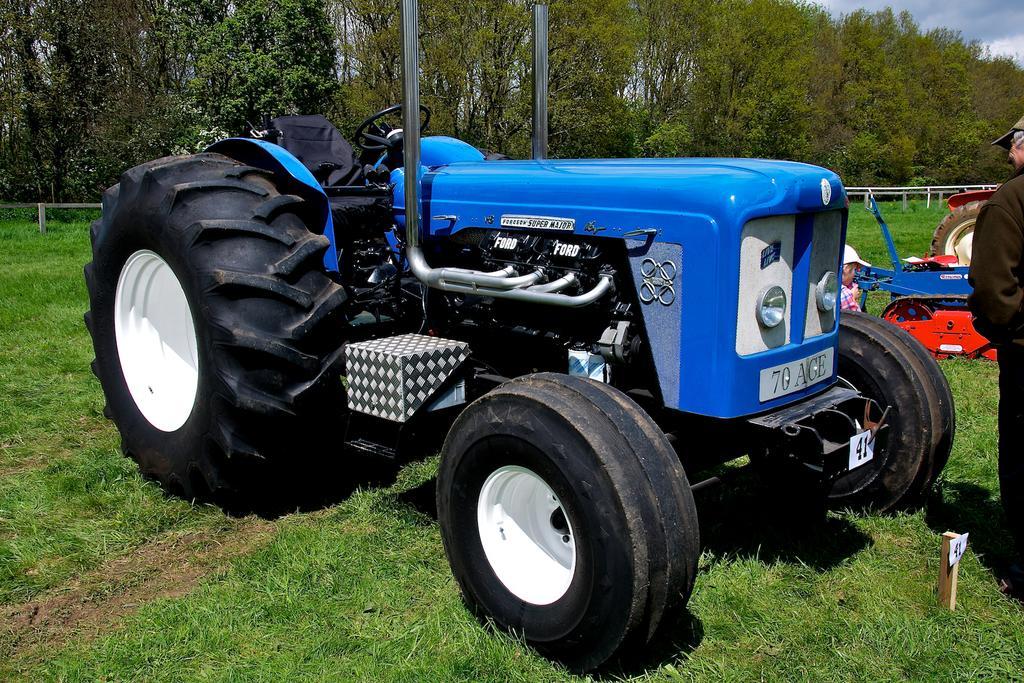Please provide a concise description of this image. In the middle of this image, there is a blue color tractor on the ground, on which there is grass. On the right side, there is a person standing. In the background, there is another person, there is a vehicle, there are trees, grass and there are clouds in the sky. 